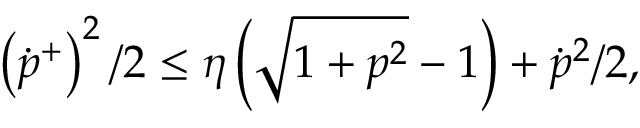Convert formula to latex. <formula><loc_0><loc_0><loc_500><loc_500>\left ( \dot { p } ^ { + } \right ) ^ { 2 } / 2 \leq \eta \left ( \sqrt { 1 + p ^ { 2 } } - 1 \right ) + \dot { p } ^ { 2 } / 2 ,</formula> 